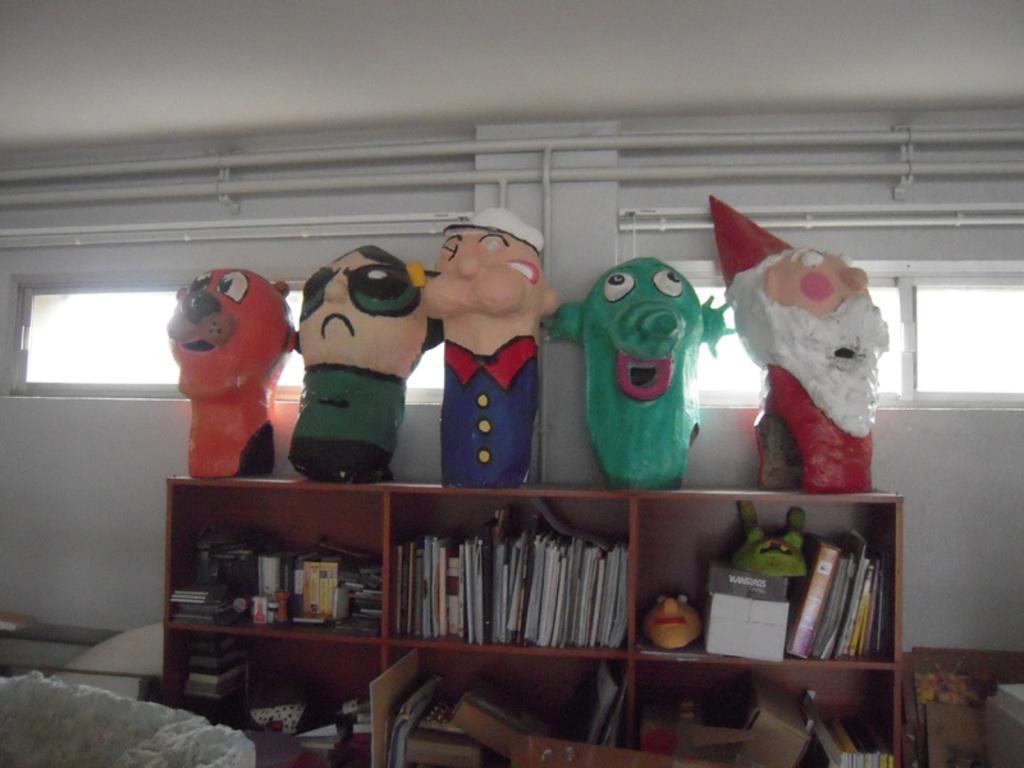In one or two sentences, can you explain what this image depicts? There is a cupboard. Inside the cupboard there are books, masks and many other items. On the cupboard there are some toys. In the back there is a wall with pipes and windows. 